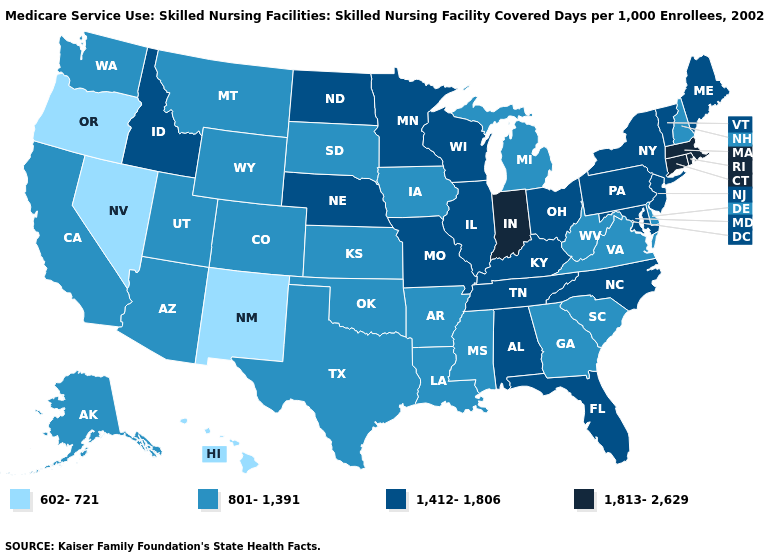Among the states that border Oklahoma , does Missouri have the highest value?
Keep it brief. Yes. Name the states that have a value in the range 801-1,391?
Concise answer only. Alaska, Arizona, Arkansas, California, Colorado, Delaware, Georgia, Iowa, Kansas, Louisiana, Michigan, Mississippi, Montana, New Hampshire, Oklahoma, South Carolina, South Dakota, Texas, Utah, Virginia, Washington, West Virginia, Wyoming. Does Indiana have the highest value in the USA?
Short answer required. Yes. Name the states that have a value in the range 1,412-1,806?
Concise answer only. Alabama, Florida, Idaho, Illinois, Kentucky, Maine, Maryland, Minnesota, Missouri, Nebraska, New Jersey, New York, North Carolina, North Dakota, Ohio, Pennsylvania, Tennessee, Vermont, Wisconsin. Which states have the lowest value in the MidWest?
Short answer required. Iowa, Kansas, Michigan, South Dakota. Does the first symbol in the legend represent the smallest category?
Give a very brief answer. Yes. What is the lowest value in states that border Alabama?
Keep it brief. 801-1,391. Does the first symbol in the legend represent the smallest category?
Answer briefly. Yes. What is the highest value in the West ?
Be succinct. 1,412-1,806. What is the value of Vermont?
Answer briefly. 1,412-1,806. Name the states that have a value in the range 801-1,391?
Give a very brief answer. Alaska, Arizona, Arkansas, California, Colorado, Delaware, Georgia, Iowa, Kansas, Louisiana, Michigan, Mississippi, Montana, New Hampshire, Oklahoma, South Carolina, South Dakota, Texas, Utah, Virginia, Washington, West Virginia, Wyoming. What is the value of Arkansas?
Answer briefly. 801-1,391. Name the states that have a value in the range 1,412-1,806?
Keep it brief. Alabama, Florida, Idaho, Illinois, Kentucky, Maine, Maryland, Minnesota, Missouri, Nebraska, New Jersey, New York, North Carolina, North Dakota, Ohio, Pennsylvania, Tennessee, Vermont, Wisconsin. Is the legend a continuous bar?
Give a very brief answer. No. What is the lowest value in the USA?
Be succinct. 602-721. 